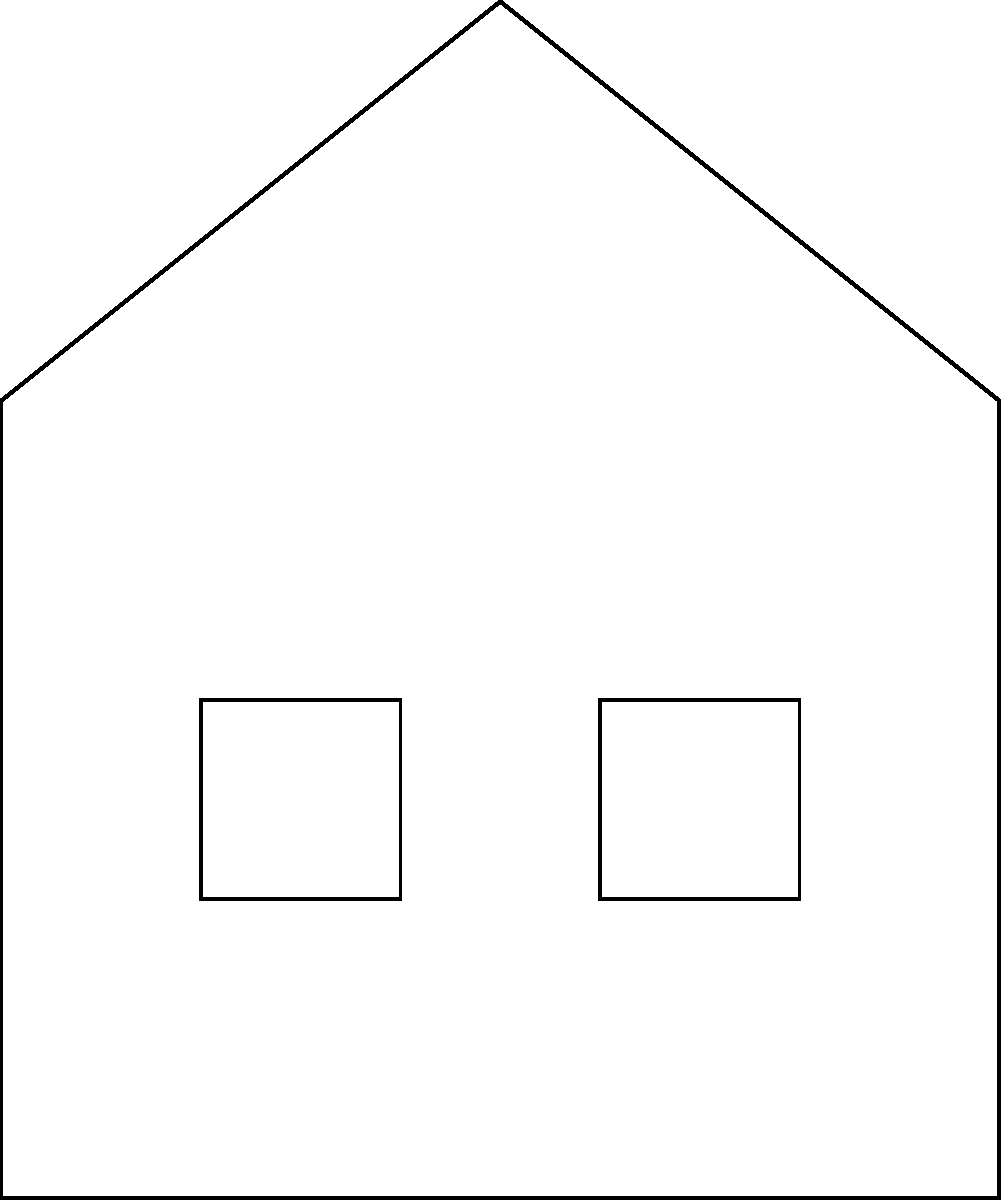In this sketch of a gothic-style haunted mansion, identify the architectural elements labeled A, B, C, and D. Which of these is most characteristic of gothic architecture? Let's examine each labeled element in the sketch:

1. Element A: This is a spire or pinnacle, a tall, slender, pointed structure on top of the building. Spires are very common in gothic architecture, often adorning church steeples and towers.

2. Element B: This appears to be an arched window, specifically a pointed arch window. Pointed arches are one of the most distinctive features of gothic architecture, replacing the rounded arches of earlier styles.

3. Element C: This is the main entrance door. While important, the door itself is not a defining characteristic of gothic architecture unless it has specific gothic elements like pointed arches or ornate carvings.

4. Element D: These are standard rectangular windows. While gothic buildings do have windows of various shapes, rectangular windows are not specifically characteristic of gothic style.

Among these elements, the most characteristic of gothic architecture is element B, the pointed arch window. Pointed arches are considered one of the hallmarks of gothic style, along with ribbed vaults and flying buttresses (not shown in this sketch). They allowed for taller, more impressively vertical structures and larger windows, both key aspects of gothic architectural aesthetics.

While spires (element A) are also common in gothic architecture, they are not as uniquely defining as the pointed arch, as they can be found in other architectural styles as well.
Answer: B (pointed arch window) 